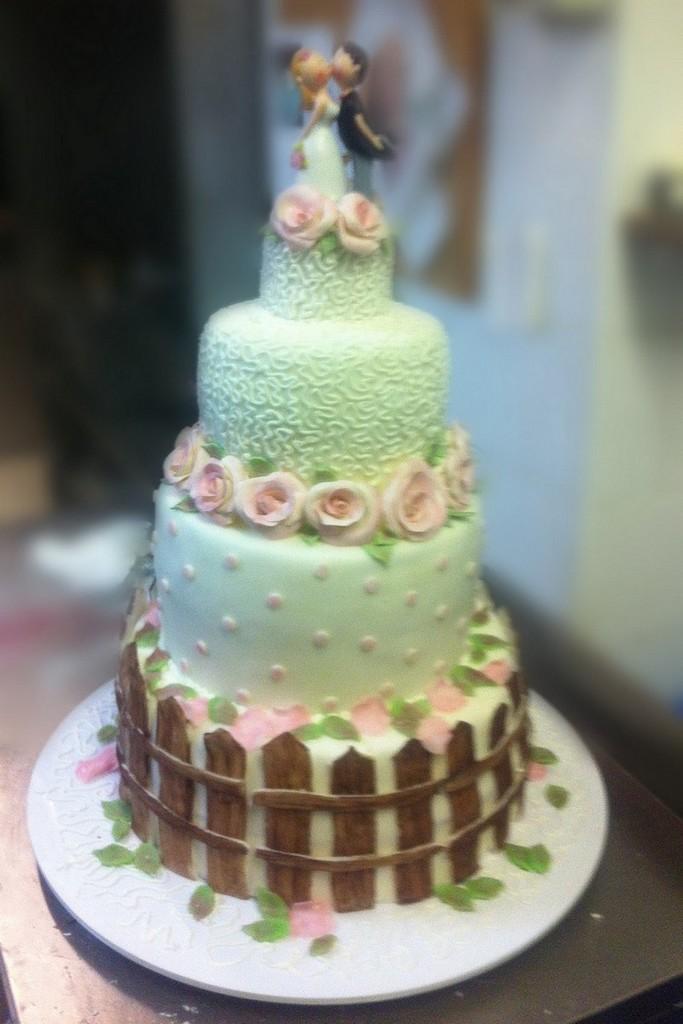In one or two sentences, can you explain what this image depicts? There is a cake on a cake base. It is on a platform. In the background it is blur. On the top of the cake there is a toy of a man and woman. Also there are flower decorations on the cake. 